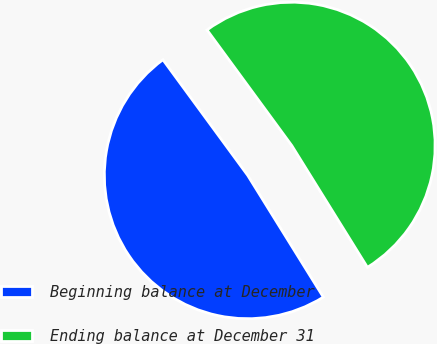Convert chart to OTSL. <chart><loc_0><loc_0><loc_500><loc_500><pie_chart><fcel>Beginning balance at December<fcel>Ending balance at December 31<nl><fcel>48.78%<fcel>51.22%<nl></chart> 